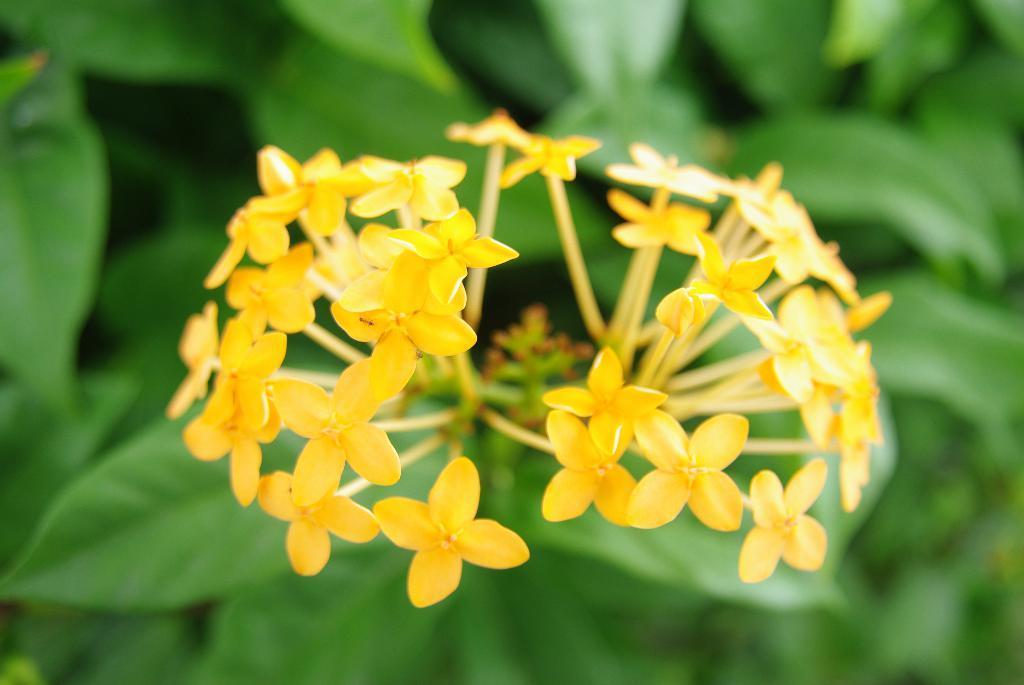Describe this image in one or two sentences. In this picture we can see yellow flowers on the plant. On the left we can see green leaves. 